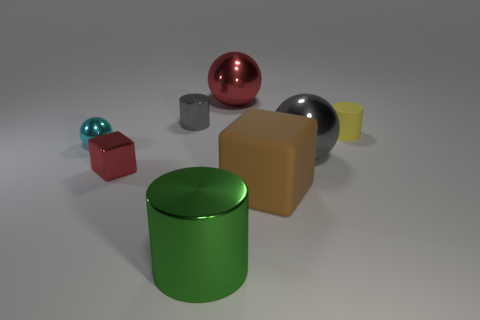Are there an equal number of small yellow rubber cylinders that are in front of the small metal sphere and small rubber objects that are to the left of the big gray metallic object?
Offer a terse response. Yes. There is a object that is to the left of the tiny block; is it the same color as the tiny cylinder that is behind the small yellow rubber cylinder?
Offer a terse response. No. Are there more tiny metallic balls that are behind the yellow thing than gray rubber balls?
Keep it short and to the point. No. The gray object that is the same material as the big gray sphere is what shape?
Offer a very short reply. Cylinder. There is a object right of the gray ball; does it have the same size as the large gray metal object?
Offer a very short reply. No. What is the shape of the gray thing right of the cylinder in front of the red metallic cube?
Keep it short and to the point. Sphere. What size is the matte thing that is on the right side of the matte thing in front of the tiny red shiny thing?
Give a very brief answer. Small. There is a sphere that is on the left side of the tiny gray thing; what is its color?
Ensure brevity in your answer.  Cyan. The brown cube that is the same material as the yellow object is what size?
Your answer should be very brief. Large. What number of yellow rubber objects have the same shape as the large gray thing?
Ensure brevity in your answer.  0. 